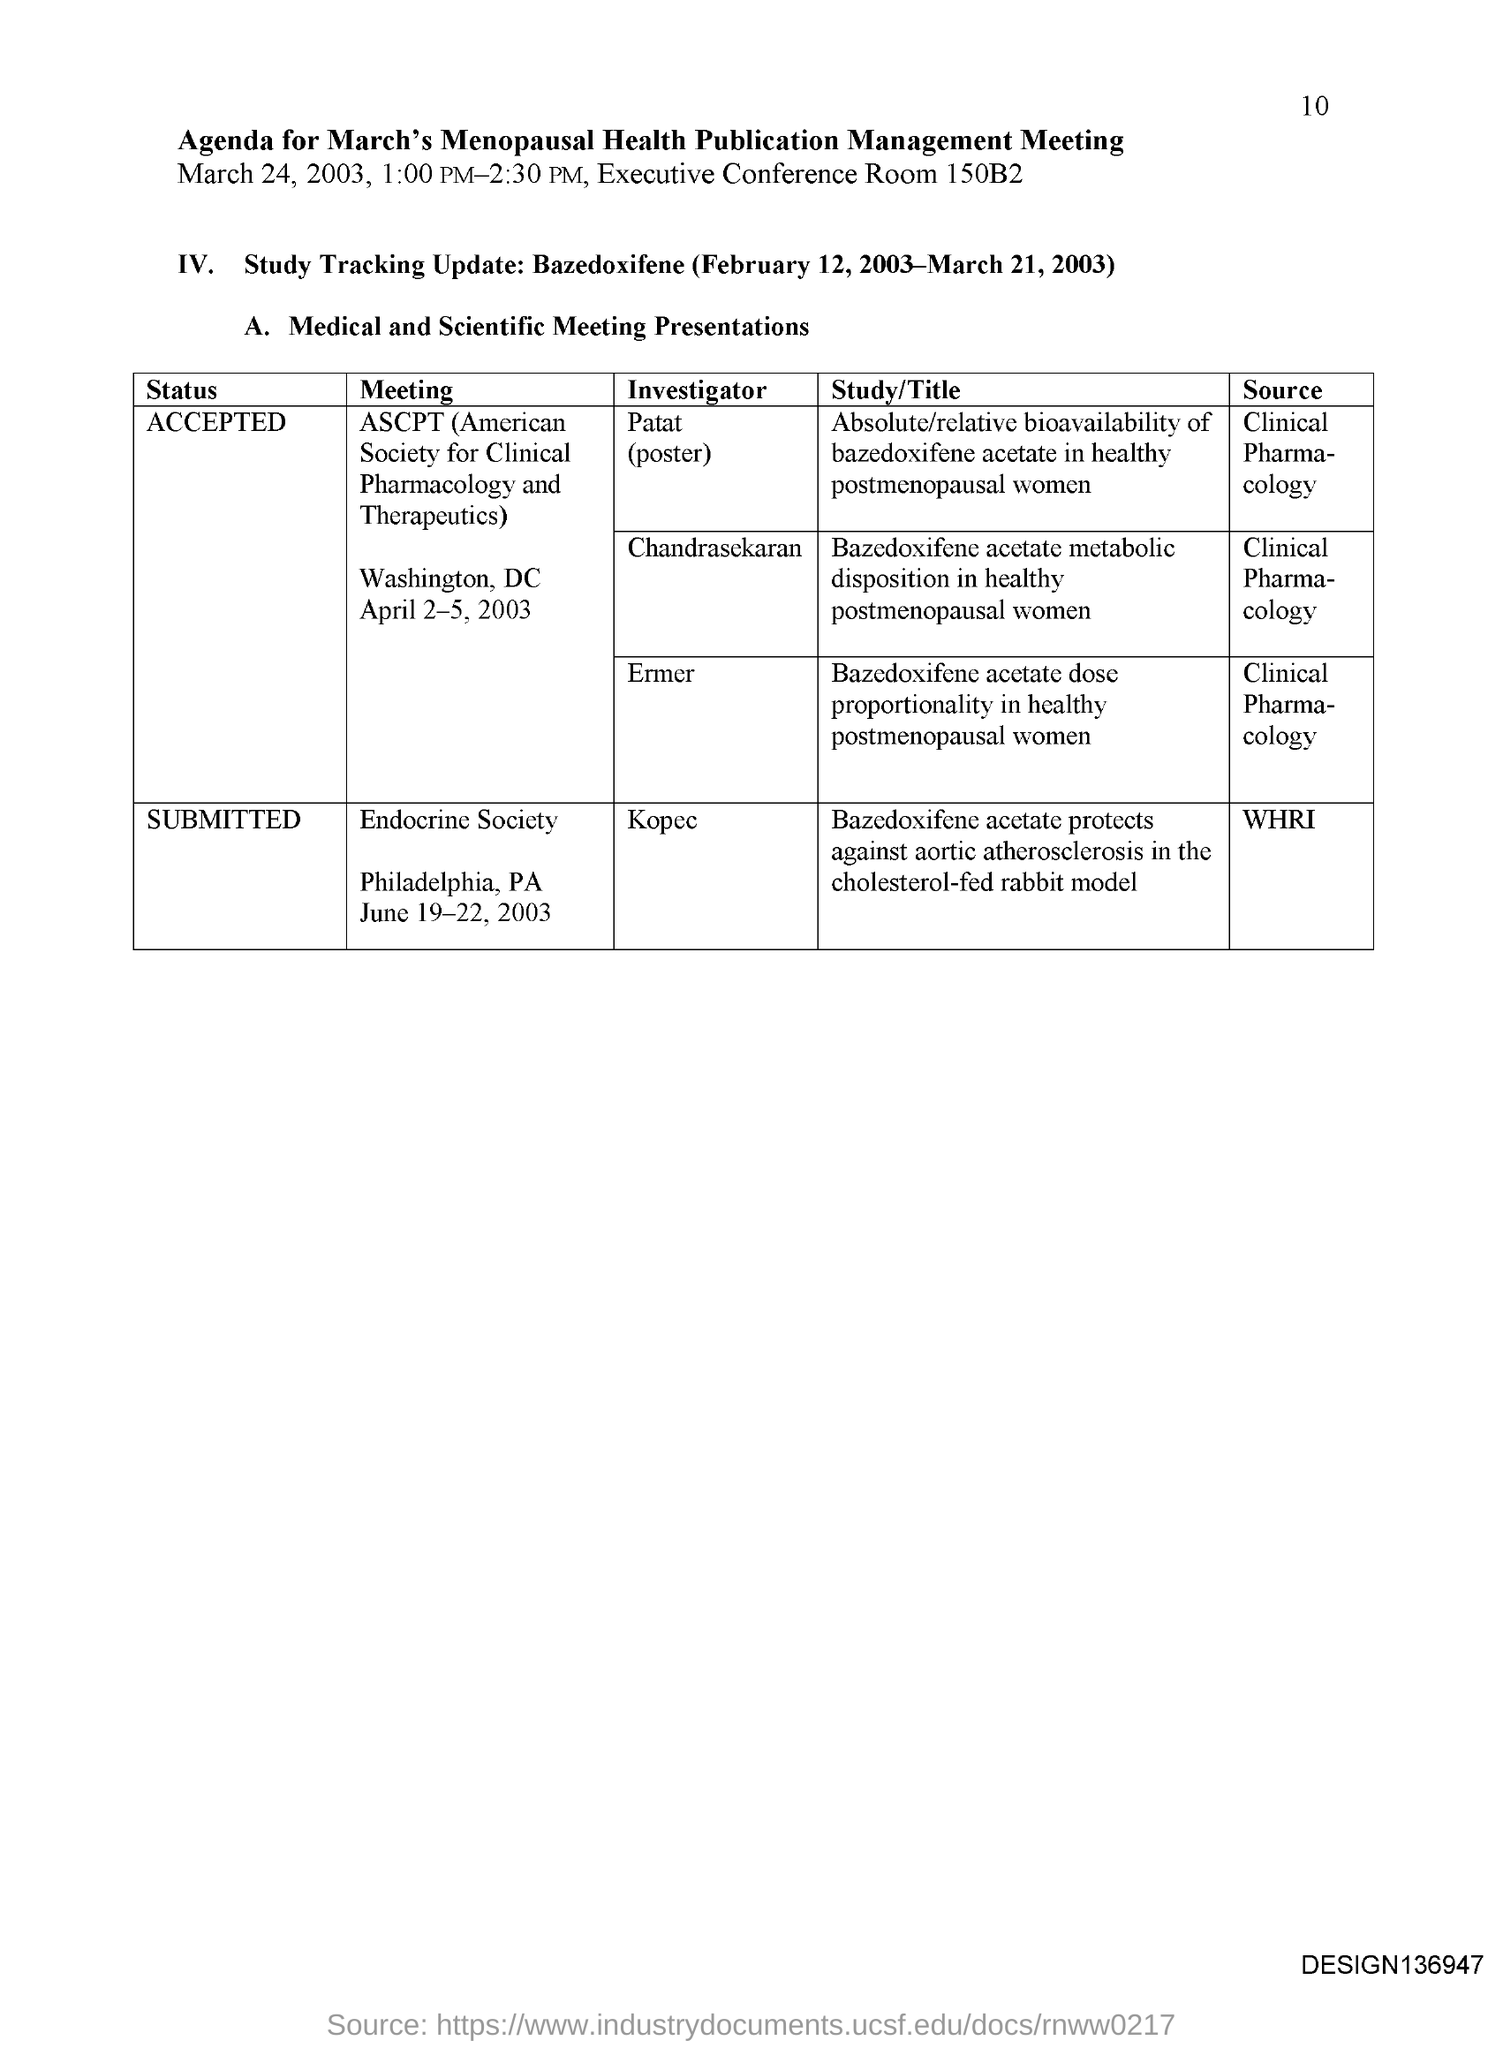List a handful of essential elements in this visual. The investigator of the meeting is the Endocrine Society, and their name is Kopec. 